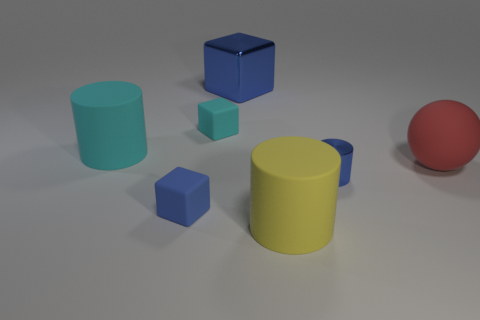Subtract 1 cylinders. How many cylinders are left? 2 Add 1 small green metallic cylinders. How many objects exist? 8 Subtract all cylinders. How many objects are left? 4 Add 6 yellow matte things. How many yellow matte things are left? 7 Add 6 big blocks. How many big blocks exist? 7 Subtract 0 blue balls. How many objects are left? 7 Subtract all metallic cylinders. Subtract all large red rubber things. How many objects are left? 5 